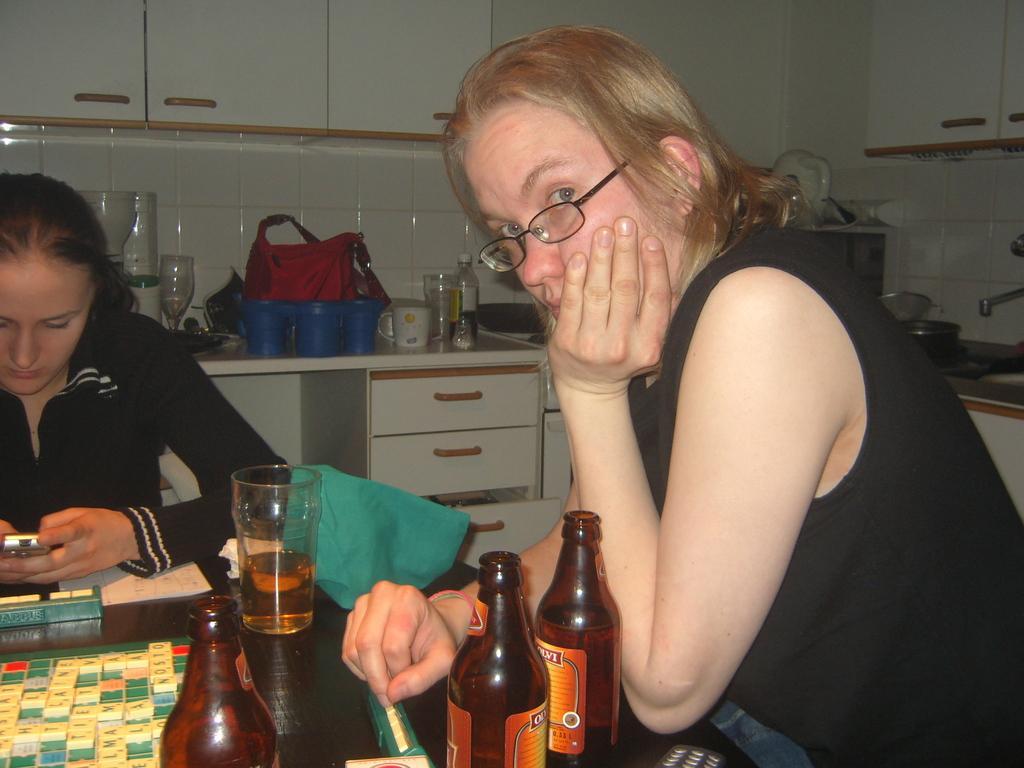In one or two sentences, can you explain what this image depicts? In this image I can see the two people. One person is holding the mobile. In front of them there are bottles and the glass and these are on the table. At the back there are some objects on the countertop. 